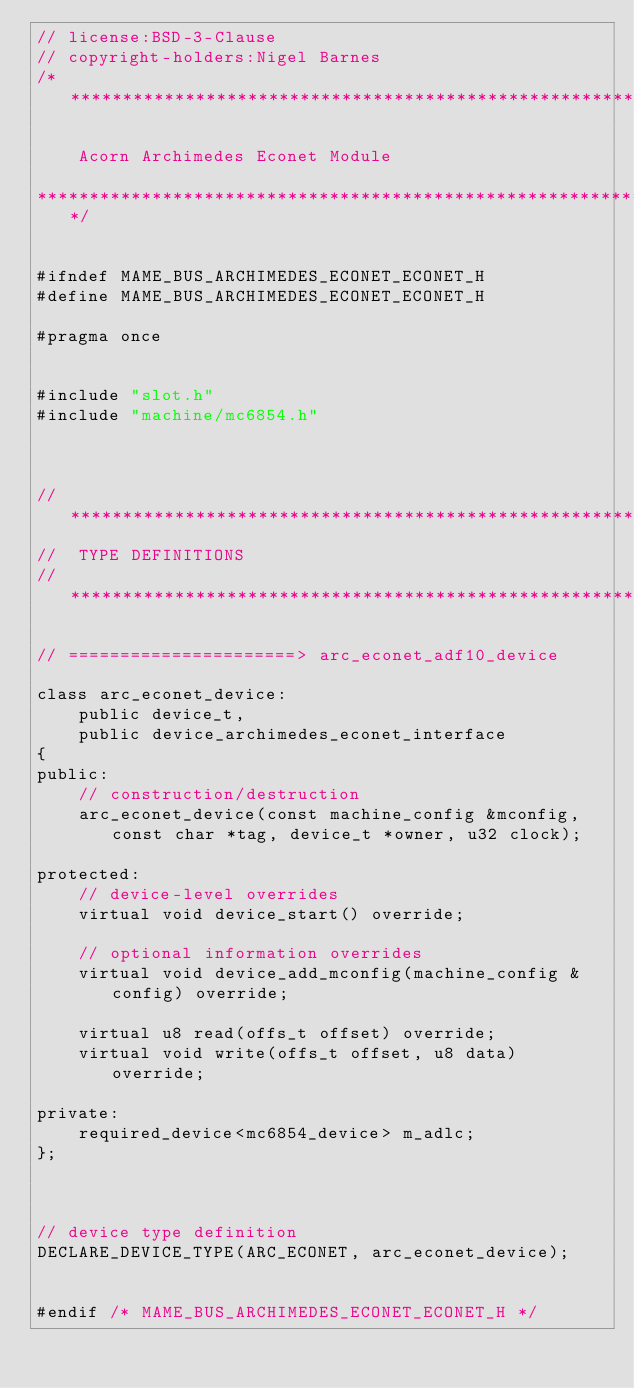Convert code to text. <code><loc_0><loc_0><loc_500><loc_500><_C_>// license:BSD-3-Clause
// copyright-holders:Nigel Barnes
/**********************************************************************

    Acorn Archimedes Econet Module

**********************************************************************/


#ifndef MAME_BUS_ARCHIMEDES_ECONET_ECONET_H
#define MAME_BUS_ARCHIMEDES_ECONET_ECONET_H

#pragma once


#include "slot.h"
#include "machine/mc6854.h"



//**************************************************************************
//  TYPE DEFINITIONS
//**************************************************************************

// ======================> arc_econet_adf10_device

class arc_econet_device:
	public device_t,
	public device_archimedes_econet_interface
{
public:
	// construction/destruction
	arc_econet_device(const machine_config &mconfig, const char *tag, device_t *owner, u32 clock);

protected:
	// device-level overrides
	virtual void device_start() override;

	// optional information overrides
	virtual void device_add_mconfig(machine_config &config) override;

	virtual u8 read(offs_t offset) override;
	virtual void write(offs_t offset, u8 data) override;

private:
	required_device<mc6854_device> m_adlc;
};



// device type definition
DECLARE_DEVICE_TYPE(ARC_ECONET, arc_econet_device);


#endif /* MAME_BUS_ARCHIMEDES_ECONET_ECONET_H */
</code> 